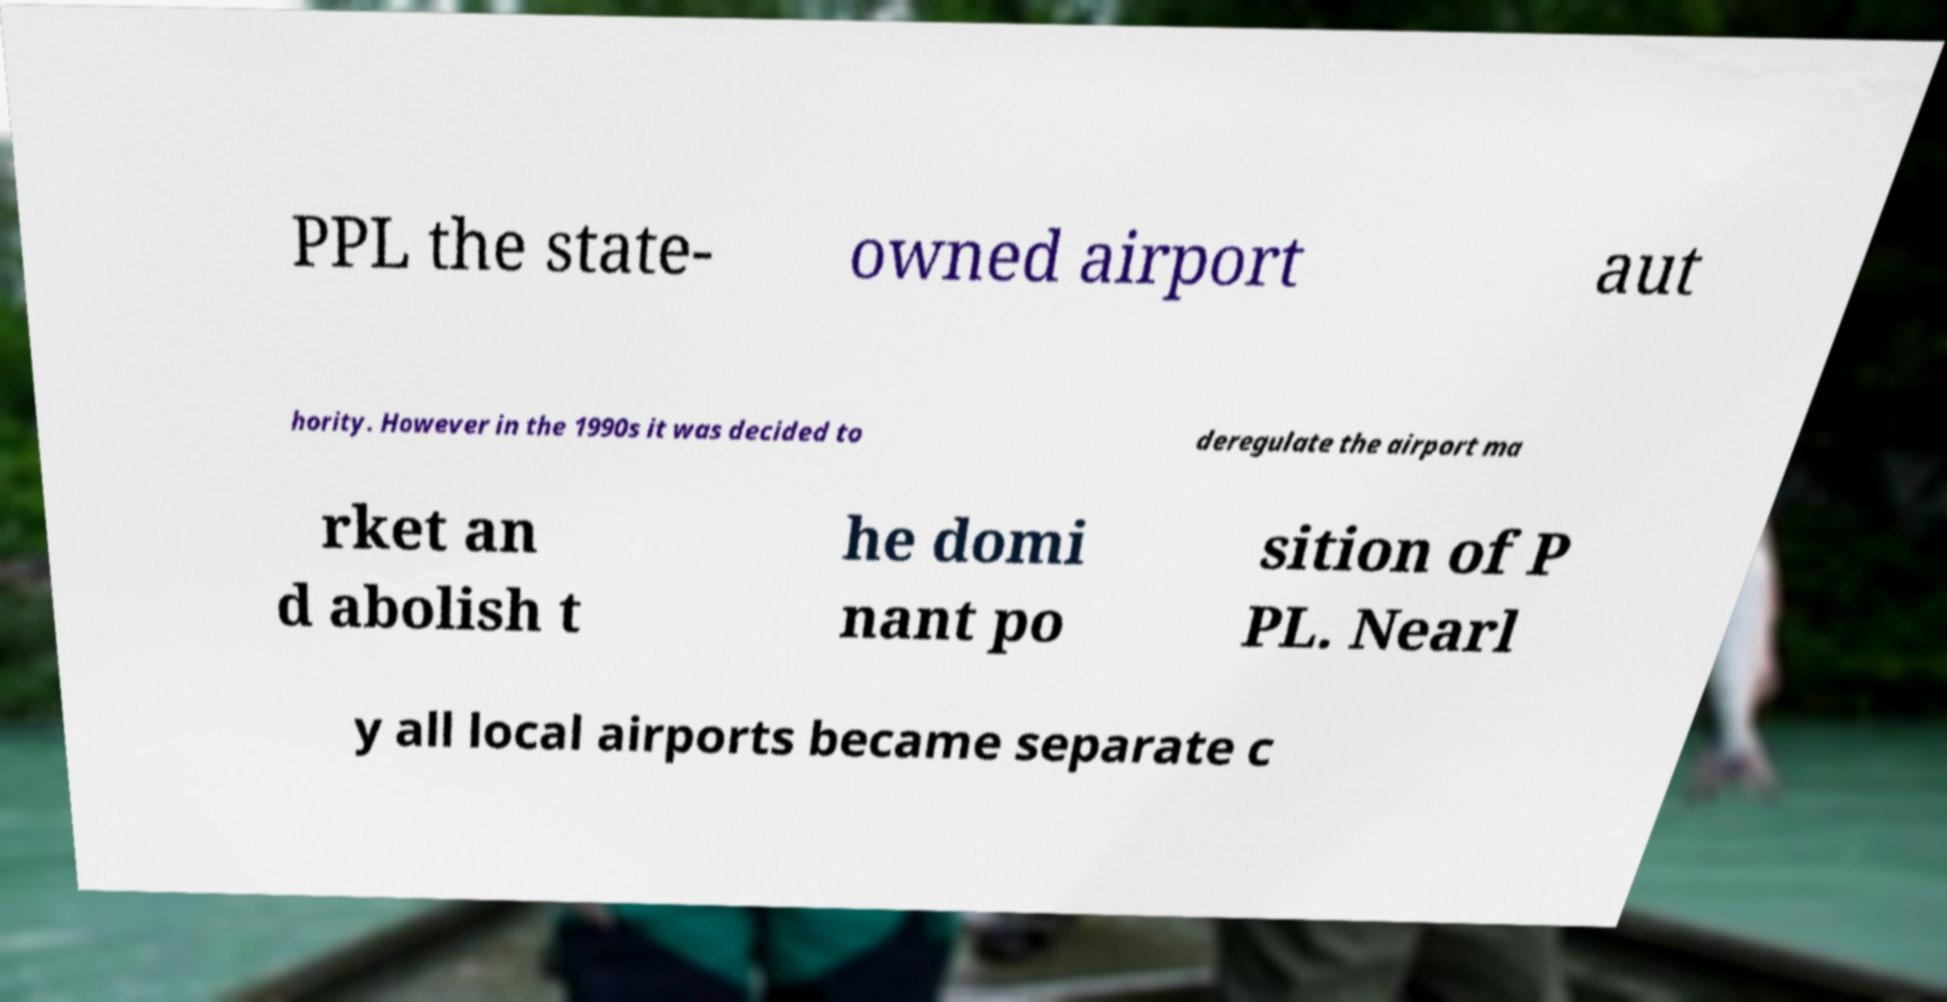For documentation purposes, I need the text within this image transcribed. Could you provide that? PPL the state- owned airport aut hority. However in the 1990s it was decided to deregulate the airport ma rket an d abolish t he domi nant po sition of P PL. Nearl y all local airports became separate c 